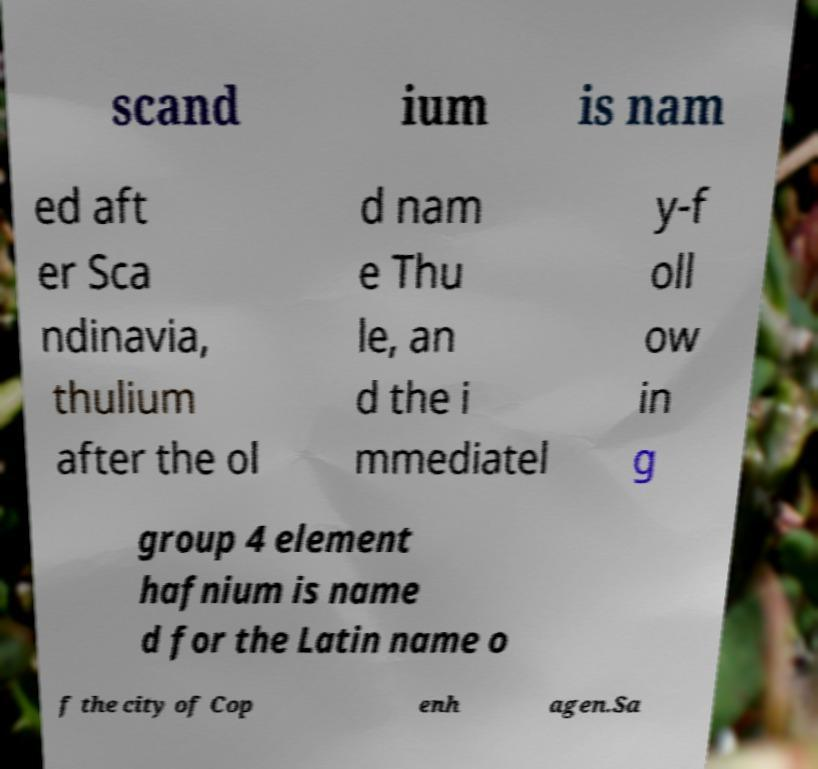Could you extract and type out the text from this image? scand ium is nam ed aft er Sca ndinavia, thulium after the ol d nam e Thu le, an d the i mmediatel y-f oll ow in g group 4 element hafnium is name d for the Latin name o f the city of Cop enh agen.Sa 